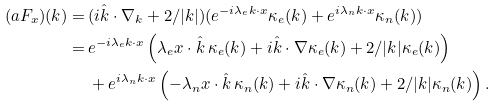Convert formula to latex. <formula><loc_0><loc_0><loc_500><loc_500>( a F _ { x } ) ( k ) = \, & ( i \hat { k } \cdot \nabla _ { k } + 2 / | k | ) ( e ^ { - i \lambda _ { e } k \cdot x } \kappa _ { e } ( k ) + e ^ { i \lambda _ { n } k \cdot x } \kappa _ { n } ( k ) ) \\ = \, & e ^ { - i \lambda _ { e } k \cdot x } \left ( \lambda _ { e } x \cdot \hat { k } \, \kappa _ { e } ( k ) + i \hat { k } \cdot \nabla \kappa _ { e } ( k ) + 2 / | k | \kappa _ { e } ( k ) \right ) \\ & + e ^ { i \lambda _ { n } k \cdot x } \left ( - \lambda _ { n } x \cdot \hat { k } \, \kappa _ { n } ( k ) + i \hat { k } \cdot \nabla \kappa _ { n } ( k ) + 2 / | k | \kappa _ { n } ( k ) \right ) .</formula> 